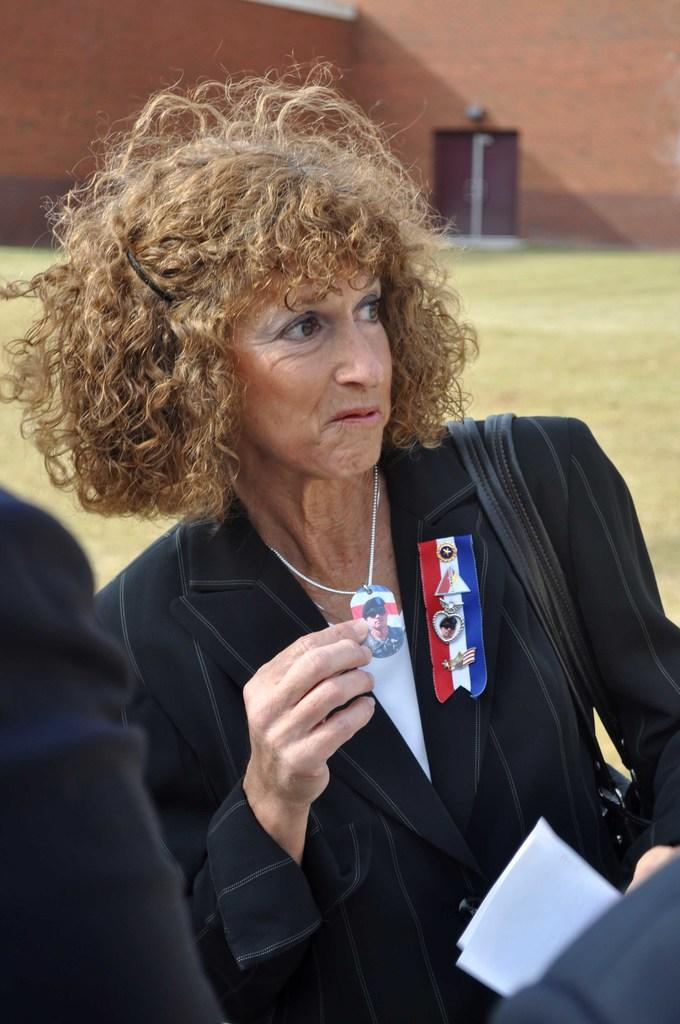Who is present in the image? There is a woman in the image. What is the woman holding in the image? The woman is holding a locket. What accessory is the woman wearing in the image? The woman is wearing a bag. What type of items can be seen in the image? Clothes are visible in the image. How would you describe the background of the image? The background of the image has a blurred view. What type of natural environment is present in the image? There is grass in the image. What type of man-made structure is present in the image? There is a wall in the image. What type of architectural feature is present in the image? There are doors in the image. What type of cart is being pulled by the woman in the image? There is no cart present in the image, and the woman is not pulling anything. What impulse caused the woman to suddenly stop in the image? There is no indication of any sudden stop or impulse in the image. 